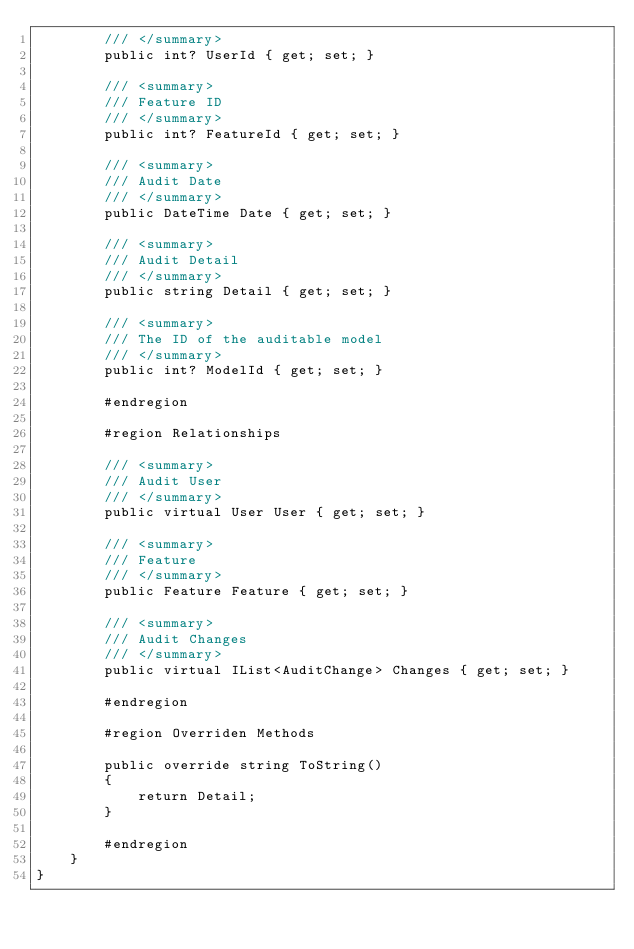Convert code to text. <code><loc_0><loc_0><loc_500><loc_500><_C#_>        /// </summary>
        public int? UserId { get; set; }

        /// <summary>
        /// Feature ID
        /// </summary>
        public int? FeatureId { get; set; }

        /// <summary>
        /// Audit Date
        /// </summary>
        public DateTime Date { get; set; }

        /// <summary>
        /// Audit Detail
        /// </summary>
        public string Detail { get; set; }

        /// <summary>
        /// The ID of the auditable model
        /// </summary>
        public int? ModelId { get; set; }

        #endregion

        #region Relationships

        /// <summary>
        /// Audit User
        /// </summary>
        public virtual User User { get; set; }

        /// <summary>
        /// Feature
        /// </summary>
        public Feature Feature { get; set; }

        /// <summary>
        /// Audit Changes
        /// </summary>
        public virtual IList<AuditChange> Changes { get; set; }

        #endregion

        #region Overriden Methods

        public override string ToString()
        {
            return Detail;
        }

        #endregion
    }
}
</code> 